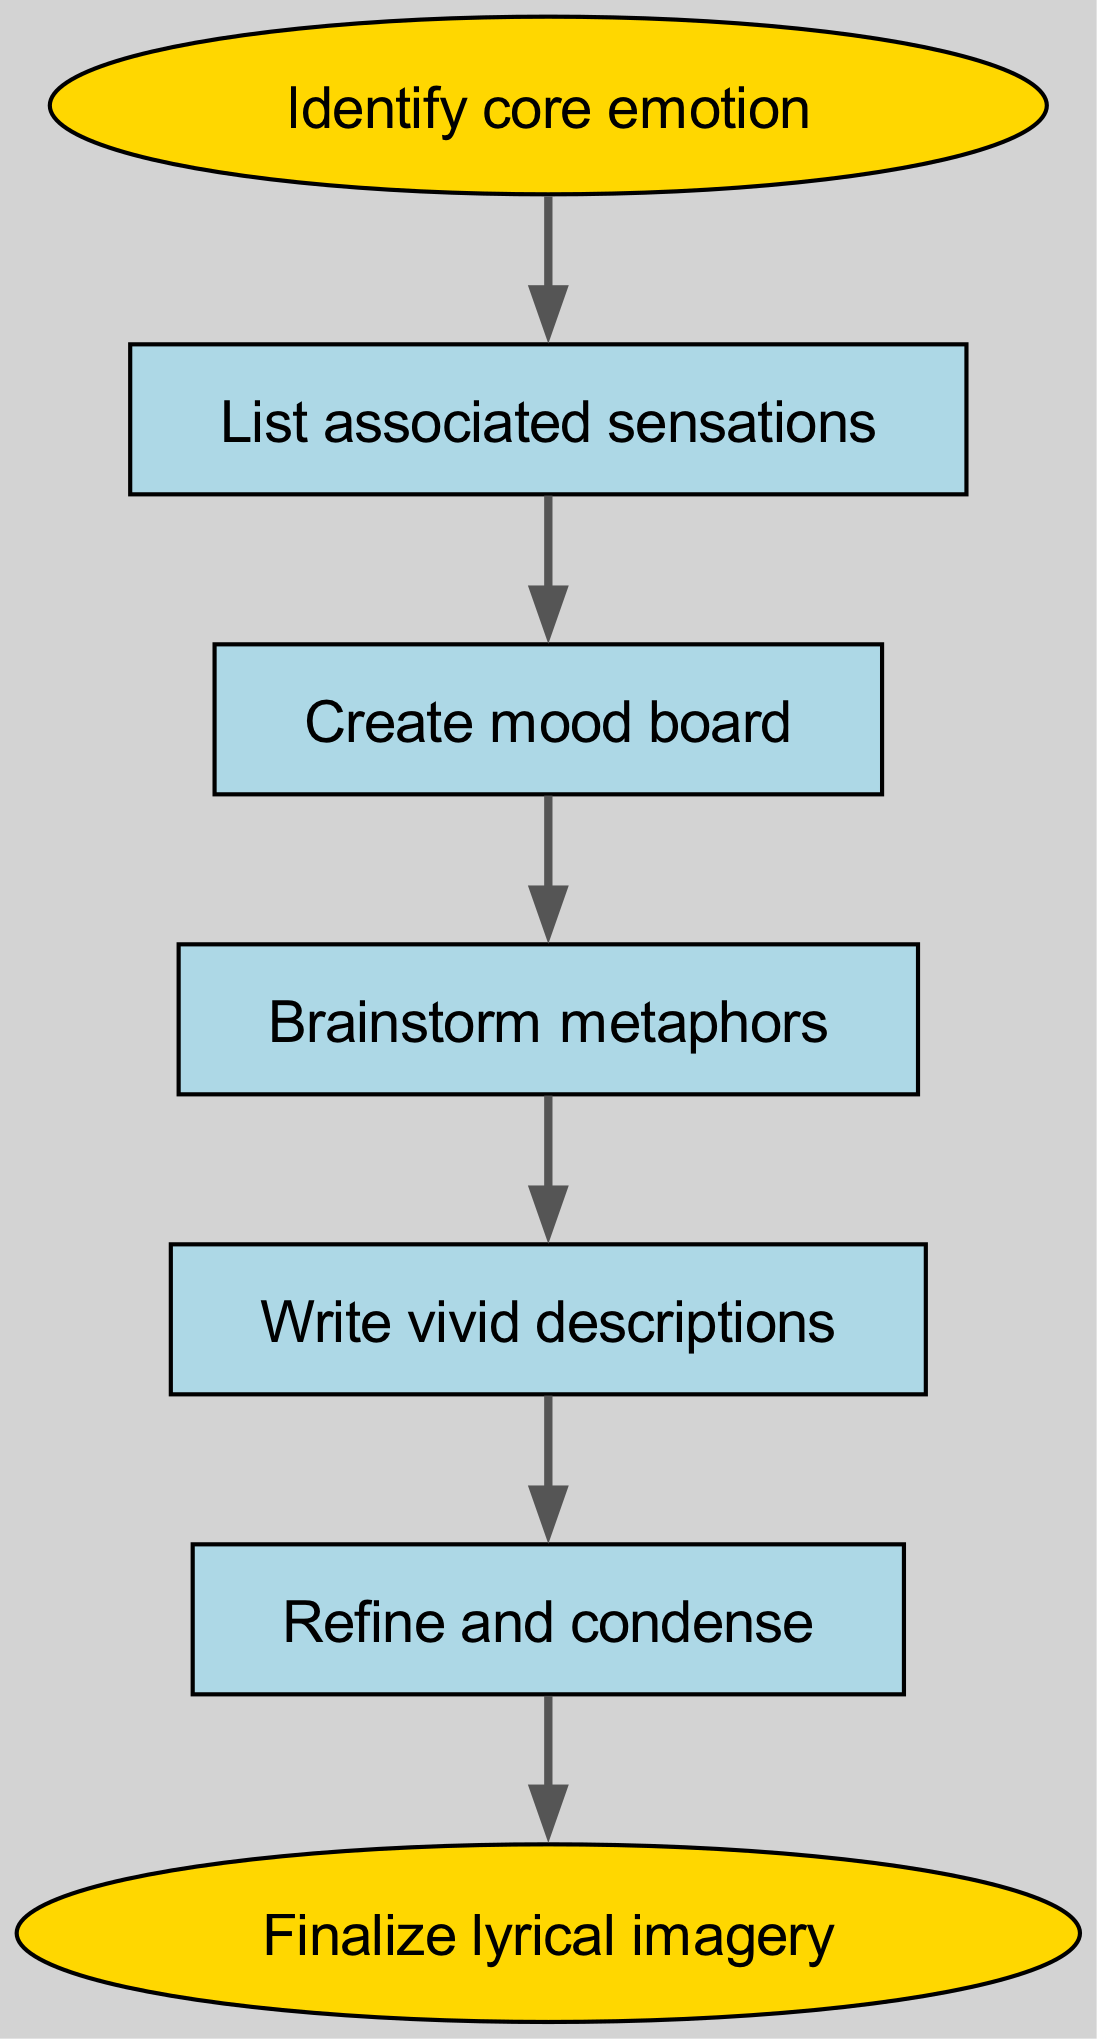What is the first step in the diagram? The diagram begins with the node labeled "Identify core emotion," which is the first step in the process of transforming abstract emotions into lyrical imagery.
Answer: Identify core emotion How many steps are there in total? The diagram contains six steps ranging from "Identify core emotion" to "Finalize lyrical imagery," including the steps in between.
Answer: Six What is the last element in the flow? The final element in the flow is labeled "Finalize lyrical imagery," indicating the completion of the lyrical imagery transformation process.
Answer: Finalize lyrical imagery Which step follows "Create mood board"? According to the flow, the step that follows "Create mood board" is "Brainstorm metaphors," which means this is the next action one should take after creating the mood board.
Answer: Brainstorm metaphors What type of node is "Identify core emotion"? The "Identify core emotion" node is an ellipse, which distinguishes it as the starting point of the flowchart from the rectangular nodes representing the middle steps.
Answer: Ellipse How is the relationship between "Write vivid descriptions" and "Refine and condense"? "Write vivid descriptions" directly leads to "Refine and condense," indicating that once vivid descriptions are written, the next action is to refine and condense those descriptions into more polished lyrical imagery.
Answer: Directly leads What is the transition from "Refine and condense" to the end? The transition from "Refine and condense" to the end is direct, meaning that after the refining process, one can finalize the lyrical imagery immediately.
Answer: Direct Which step does "Brainstorm metaphors" directly connect to? "Brainstorm metaphors" directly connects to "Write vivid descriptions," meaning that after brainstorming metaphors, the next step is to write out vivid descriptions based on those metaphors.
Answer: Write vivid descriptions 